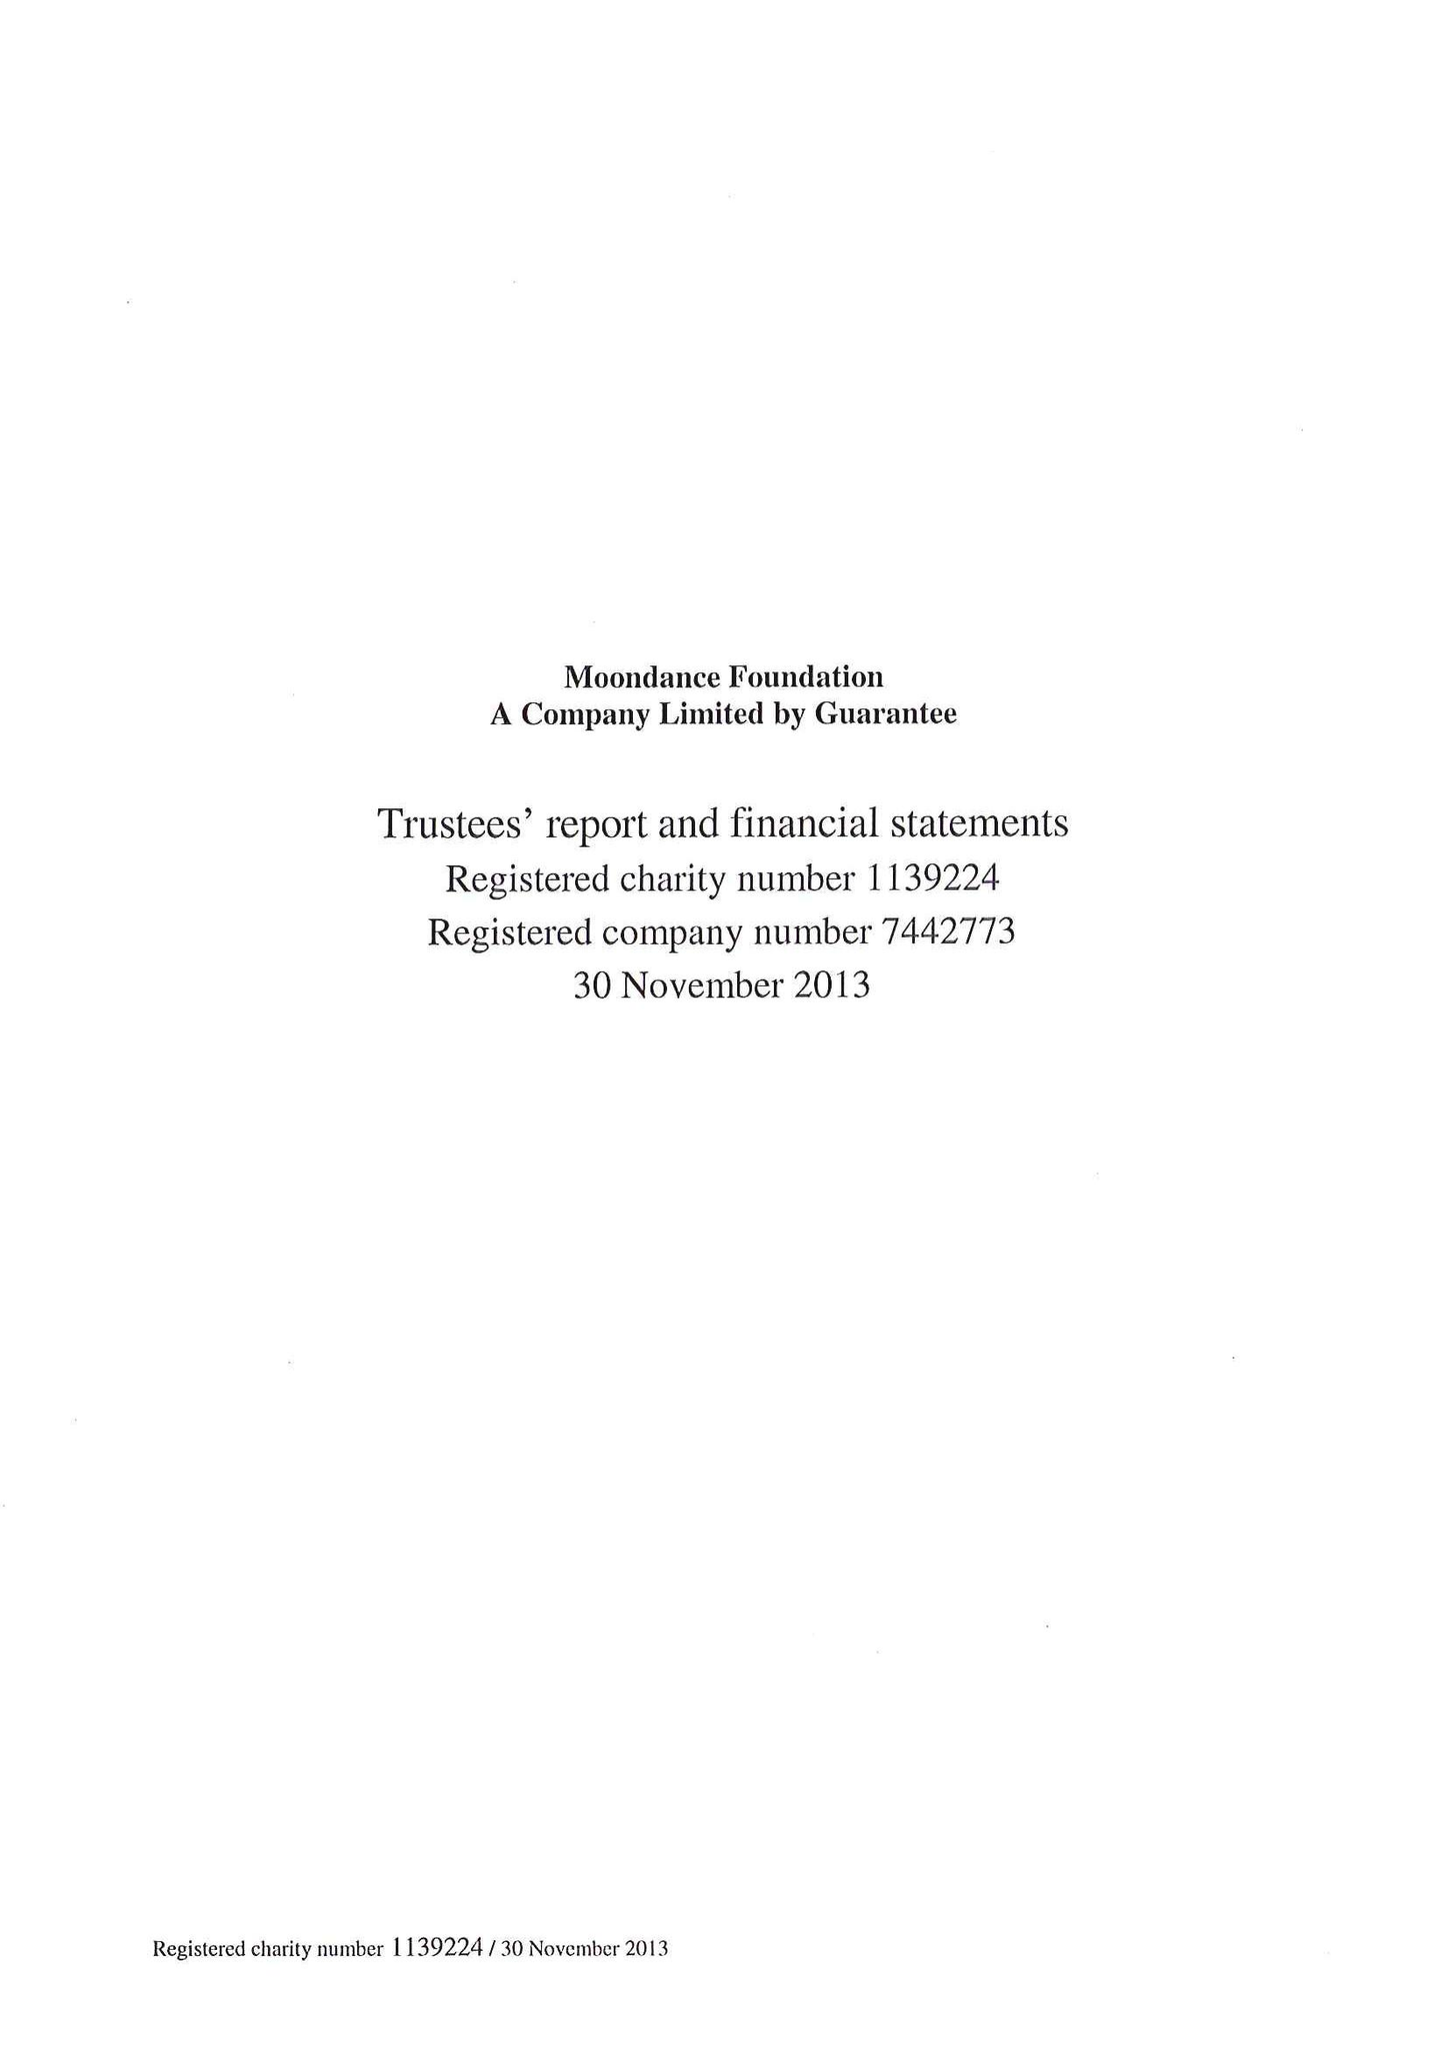What is the value for the report_date?
Answer the question using a single word or phrase. 2013-11-30 